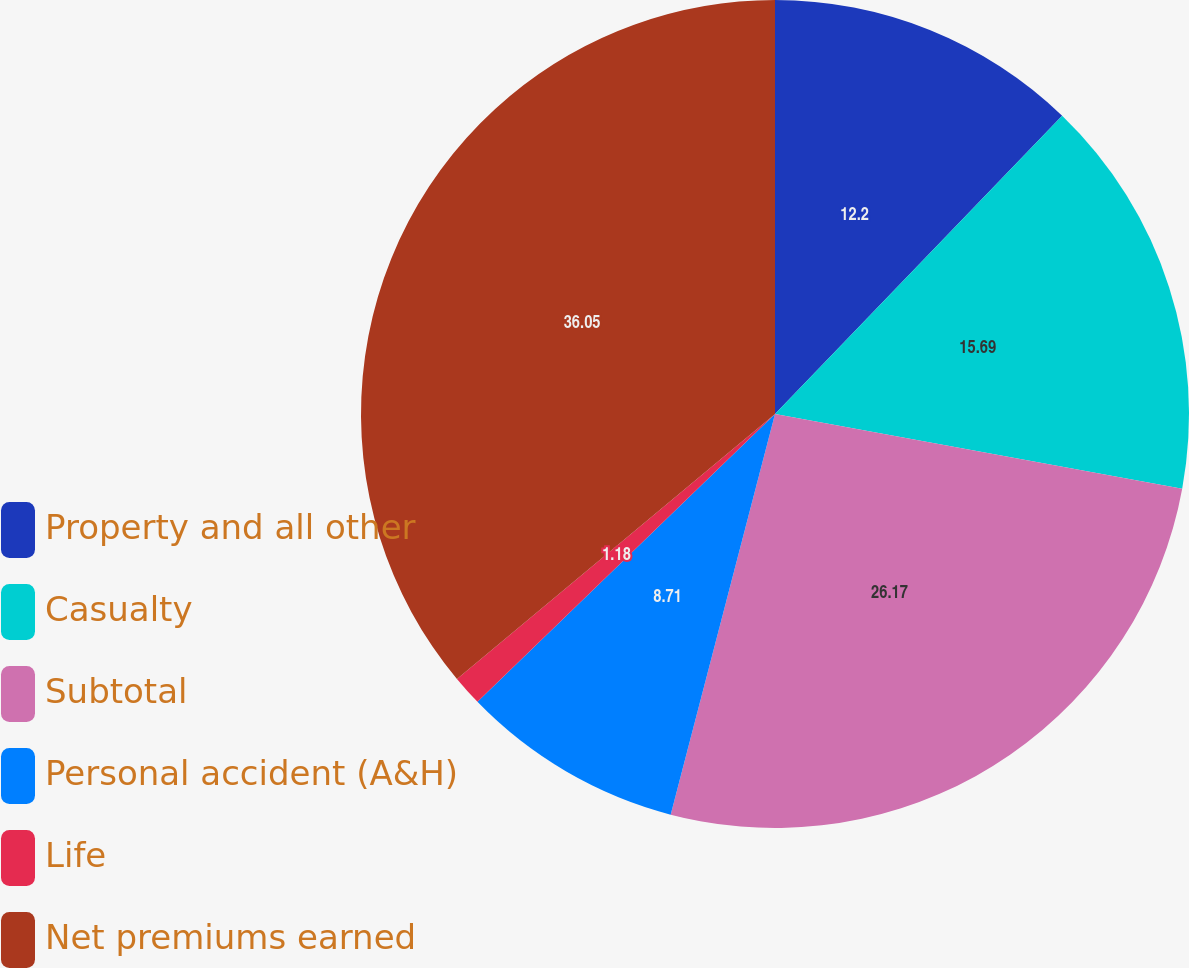Convert chart. <chart><loc_0><loc_0><loc_500><loc_500><pie_chart><fcel>Property and all other<fcel>Casualty<fcel>Subtotal<fcel>Personal accident (A&H)<fcel>Life<fcel>Net premiums earned<nl><fcel>12.2%<fcel>15.69%<fcel>26.17%<fcel>8.71%<fcel>1.18%<fcel>36.06%<nl></chart> 